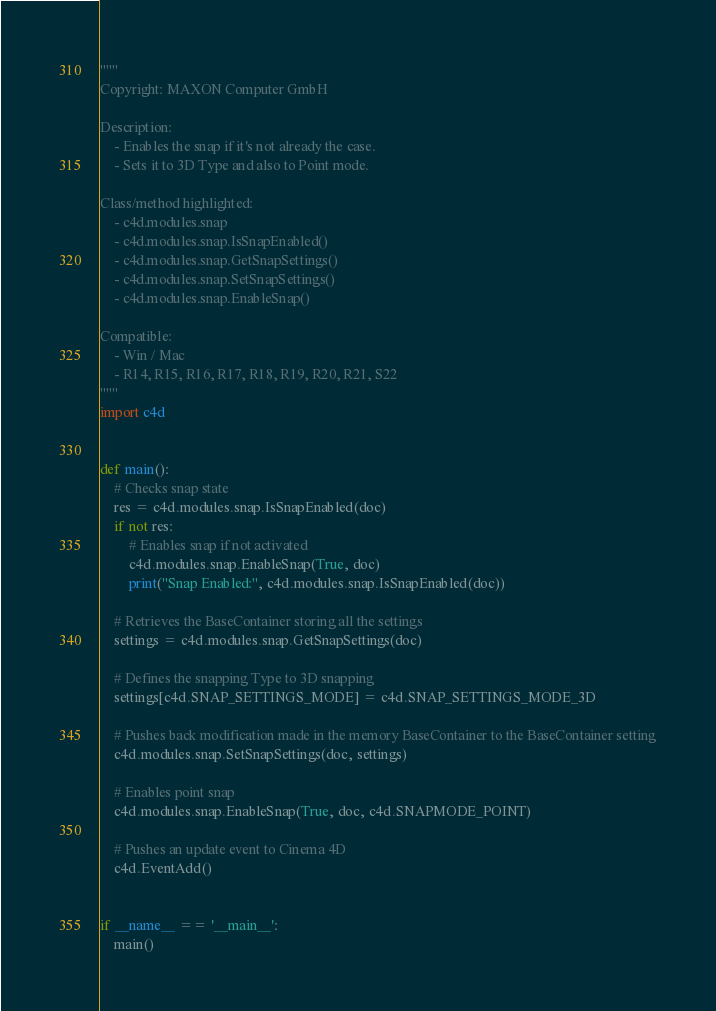<code> <loc_0><loc_0><loc_500><loc_500><_Python_>"""
Copyright: MAXON Computer GmbH

Description:
    - Enables the snap if it's not already the case.
    - Sets it to 3D Type and also to Point mode.

Class/method highlighted:
    - c4d.modules.snap
    - c4d.modules.snap.IsSnapEnabled()
    - c4d.modules.snap.GetSnapSettings()
    - c4d.modules.snap.SetSnapSettings()
    - c4d.modules.snap.EnableSnap()

Compatible:
    - Win / Mac
    - R14, R15, R16, R17, R18, R19, R20, R21, S22
"""
import c4d


def main():
    # Checks snap state
    res = c4d.modules.snap.IsSnapEnabled(doc)
    if not res:
        # Enables snap if not activated
        c4d.modules.snap.EnableSnap(True, doc)
        print("Snap Enabled:", c4d.modules.snap.IsSnapEnabled(doc))

    # Retrieves the BaseContainer storing all the settings
    settings = c4d.modules.snap.GetSnapSettings(doc)

    # Defines the snapping Type to 3D snapping
    settings[c4d.SNAP_SETTINGS_MODE] = c4d.SNAP_SETTINGS_MODE_3D

    # Pushes back modification made in the memory BaseContainer to the BaseContainer setting
    c4d.modules.snap.SetSnapSettings(doc, settings)

    # Enables point snap
    c4d.modules.snap.EnableSnap(True, doc, c4d.SNAPMODE_POINT)

    # Pushes an update event to Cinema 4D
    c4d.EventAdd()


if __name__ == '__main__':
    main()
</code> 